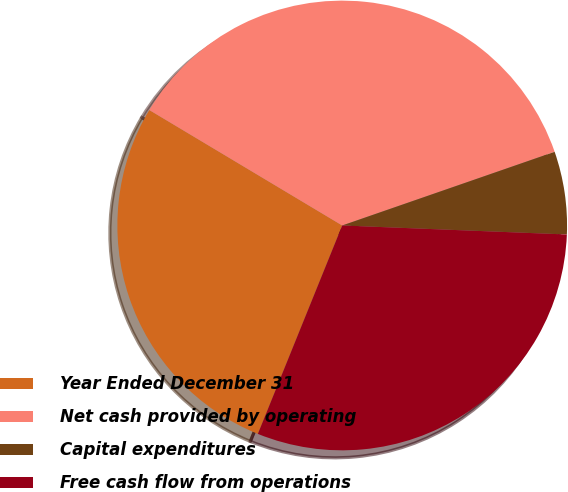Convert chart. <chart><loc_0><loc_0><loc_500><loc_500><pie_chart><fcel>Year Ended December 31<fcel>Net cash provided by operating<fcel>Capital expenditures<fcel>Free cash flow from operations<nl><fcel>27.46%<fcel>36.1%<fcel>5.95%<fcel>30.48%<nl></chart> 